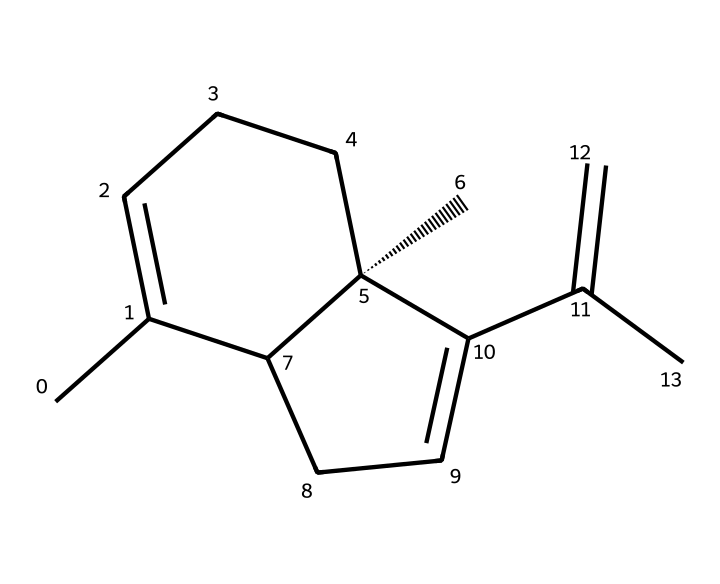What is the molecular formula of caryophyllene? To determine the molecular formula, we need to count each type of atom present in the structure based on the SMILES representation. Counting the carbons (C) and hydrogens (H), we find a total of 15 carbon atoms and 24 hydrogen atoms. The molecular formula is written as C15H24.
Answer: C15H24 How many rings are present in caryophyllene's structure? We analyze the structure to identify cyclic (ring) formations. In caryophyllene, there are two rings, as indicated by the cycloalkane structure seen in the SMILES.
Answer: 2 What type of functional groups are present in caryophyllene? By examining the structure, we look for functional groups. Caryophyllene primarily consists of hydrocarbons and does not contain any notable functional groups like alcohols or ketones. The presence of only carbon and hydrogen signifies that it's a terpene.
Answer: None What is the significance of the double bonds in caryophyllene? The double bonds in caryophyllene are indicative of unsaturation and contribute to its reactivity and potential biological activities, such as anti-inflammatory properties. Each double bond alters the molecular conformation and stability, allowing for interaction with biological systems.
Answer: Anti-inflammatory properties What configuration does caryophyllene possess at its chiral center? A key feature in caryophyllene is the presence of a chiral center as indicated by the notation [C@] in the SMILES representation. This implies a specific spatial arrangement (R/S configuration) that may influence its biological activity.
Answer: Chiral What is the role of caryophyllene in plants? Caryophyllene is often produced by plants as a defensive compound against herbivores and pathogens, reflecting its ecological role in plant resilience and the herbivore-response mechanism.
Answer: Defense mechanism Are terpenes like caryophyllene aromatic? To explore the aromatic nature, we check for the presence of conjugated double bonds in cyclic structures. While caryophyllene has double bonds, it does not have a fully conjugated system like those seen in aromatic compounds. Thus, it is classified as a non-aromatic terpene.
Answer: Non-aromatic 